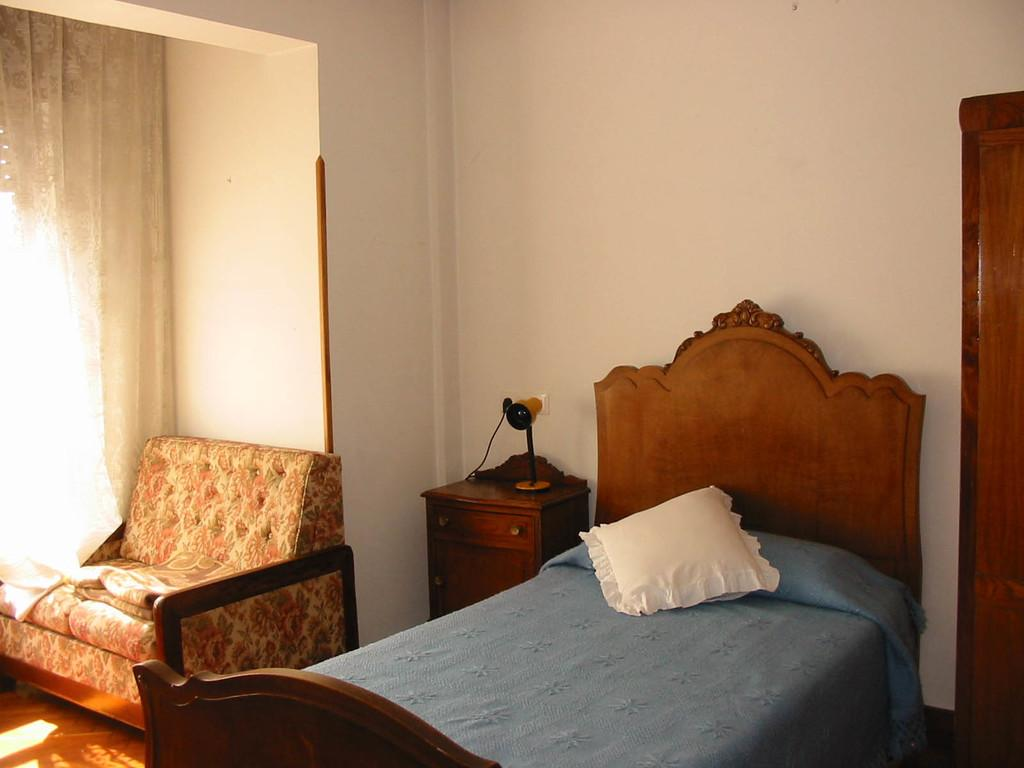What type of furniture is in the image that people can sleep on? There is a cot in the image that people can sleep on. What is placed on the cot for comfort? There is a pillow on the cot. What type of structure can be seen in the background of the image? There is a wall visible in the image. What type of seating is in the image? There is a sofa in the image. What type of window treatment is present in the image? There is a curtain in the image. How many zephyrs are visible in the image? There are no zephyrs present in the image. Is there a bike in the image? No, there is no bike in the image. 